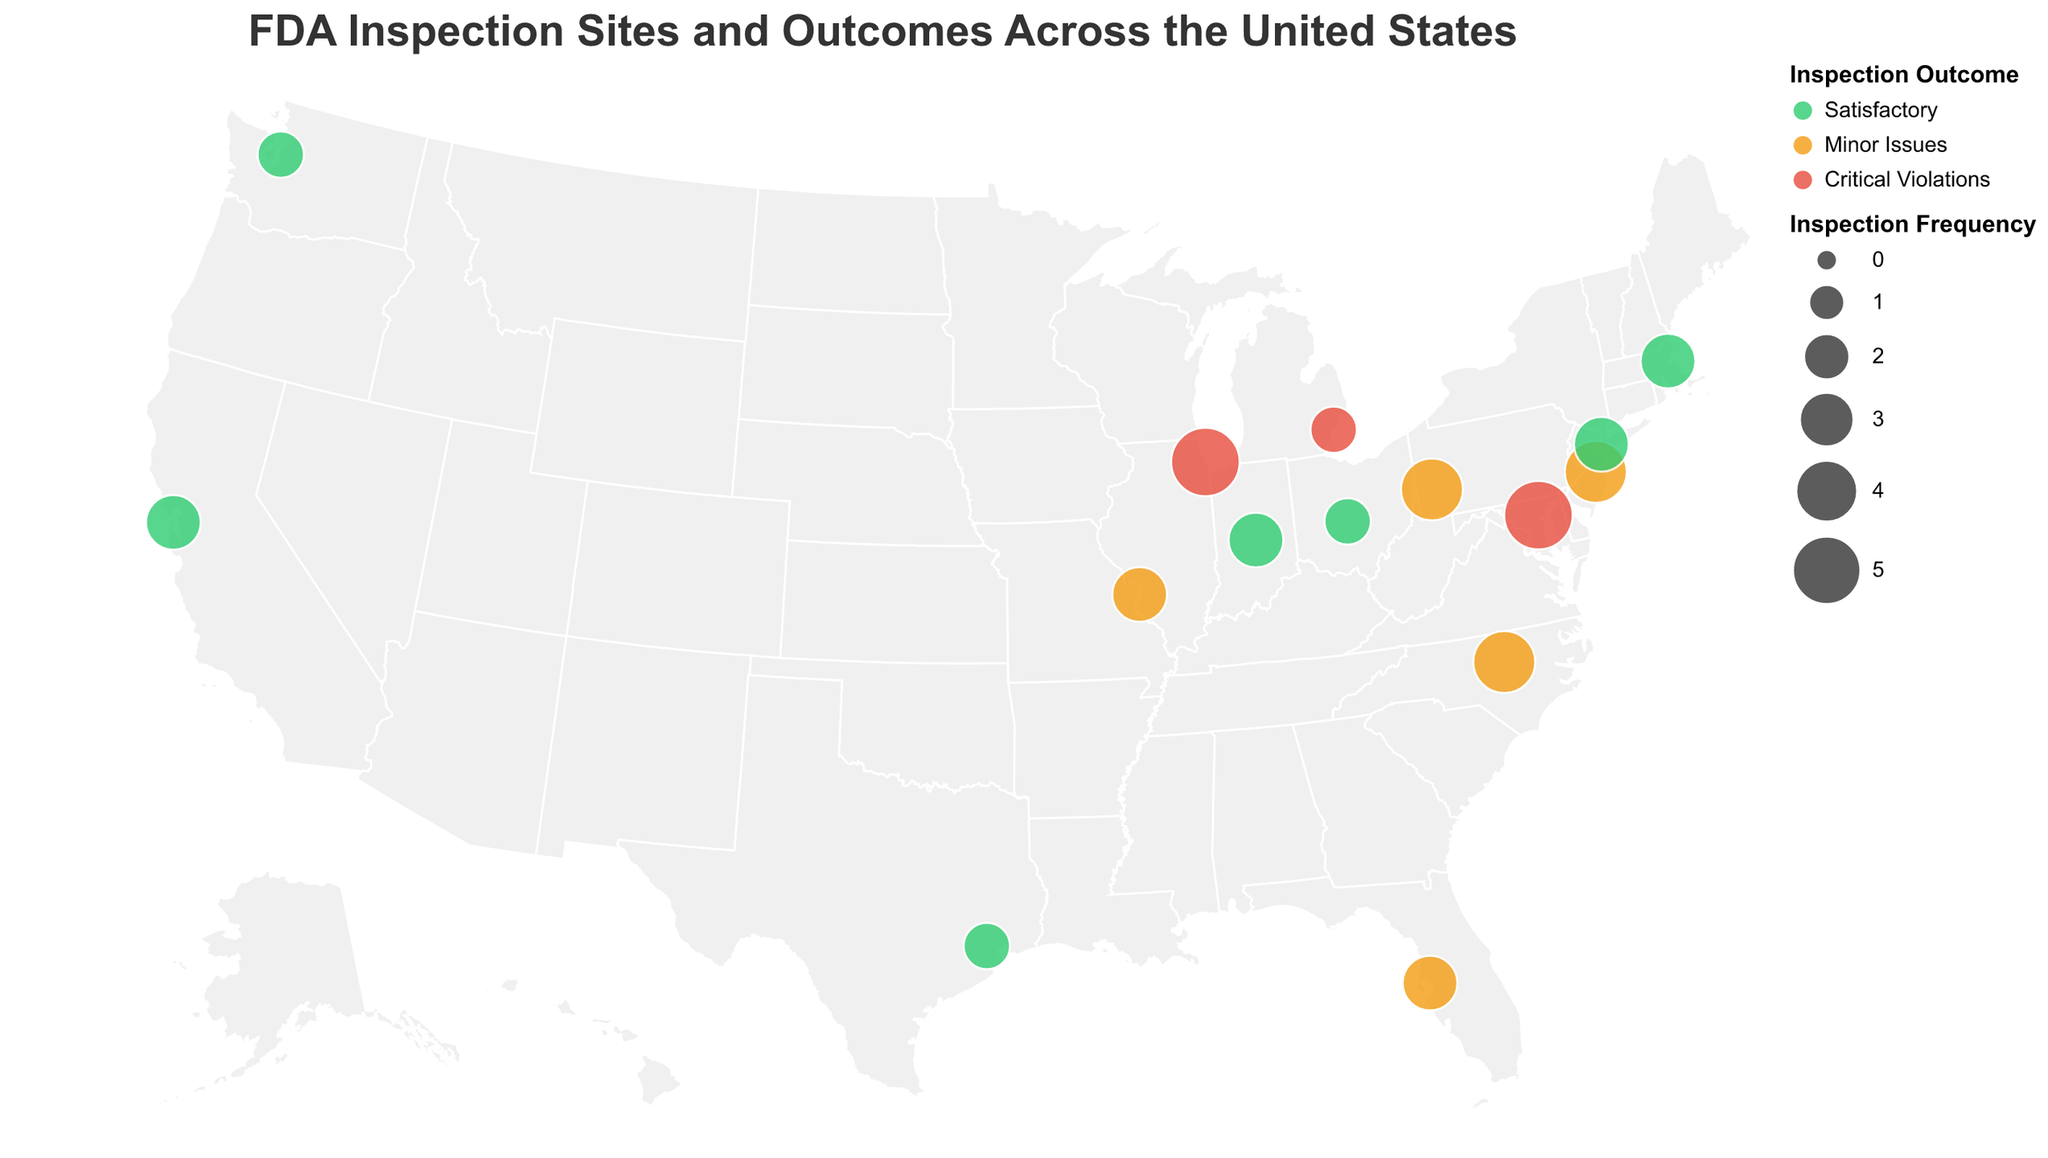What is the title of the geographic plot? The title is displayed at the top of the plot. It reads "FDA Inspection Sites and Outcomes Across the United States".
Answer: FDA Inspection Sites and Outcomes Across the United States Which facility has the highest inspection frequency and what is the outcome of its inspections? From the plot, the size of the circles represents the inspection frequency. The largest circles correspond to "Abbott Laboratories" in Illinois, "Emergent BioSolutions" in Maryland, both with an inspection frequency of 5. The outcome of both inspections is "Critical Violations".
Answer: Abbott Laboratories (Critical Violations), Emergent BioSolutions (Critical Violations) How many facilities have a satisfactory inspection outcome? These facilities are color-coded in green. By counting the green circles on the map, we find there are six facilities with a satisfactory outcome.
Answer: 6 Which state has the most FDA inspection sites and what are their outcomes? Each facility is mapped by location. New Jersey and North Carolina each have one facility with an outcome of "Minor Issues". Since no state has more than one site mapped, there is no state with multiple facilities on the plot based on the provided data.
Answer: No state with multiple listed sites Compare the inspection frequencies of Bristol-Myers Squibb in New York and Cardinal Health in Ohio. Which one is greater? By locating the respective circles and comparing their sizes, "Bristol-Myers Squibb" in New York has an inspection frequency of 3, while "Cardinal Health" in Ohio has a frequency of 2.
Answer: Bristol-Myers Squibb (3) How many facilities have "Critical Violations" as their inspection outcome? These are represented by red color. By counting the red circles, three facilities fall into this category: Abbott Laboratories in Illinois, Perrigo Company in Michigan, Emergent BioSolutions in Maryland.
Answer: 3 What can you infer about the geographic distribution of satisfactory inspection outcomes? The green circles representing satisfactory outcomes are spread across different states, including California, Texas, Massachusetts, Indiana, New York, Ohio, and Washington, indicating a diverse geographic distribution.
Answer: Diverse geographic distribution Which facility in Massachusetts had inspections and what was the result? Look at the plot and find Massachusetts; the circle there represents "Moderna Therapeutics". The inspection outcome color is green, indicating "Satisfactory".
Answer: Moderna Therapeutics, Satisfactory 